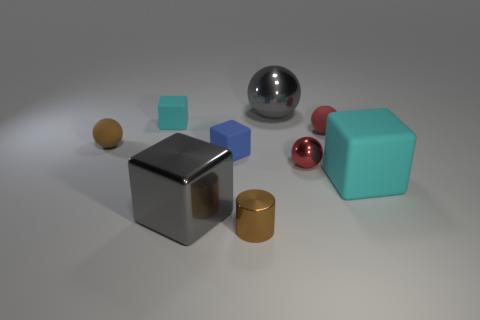Are there more blue cubes than tiny red cubes? yes 